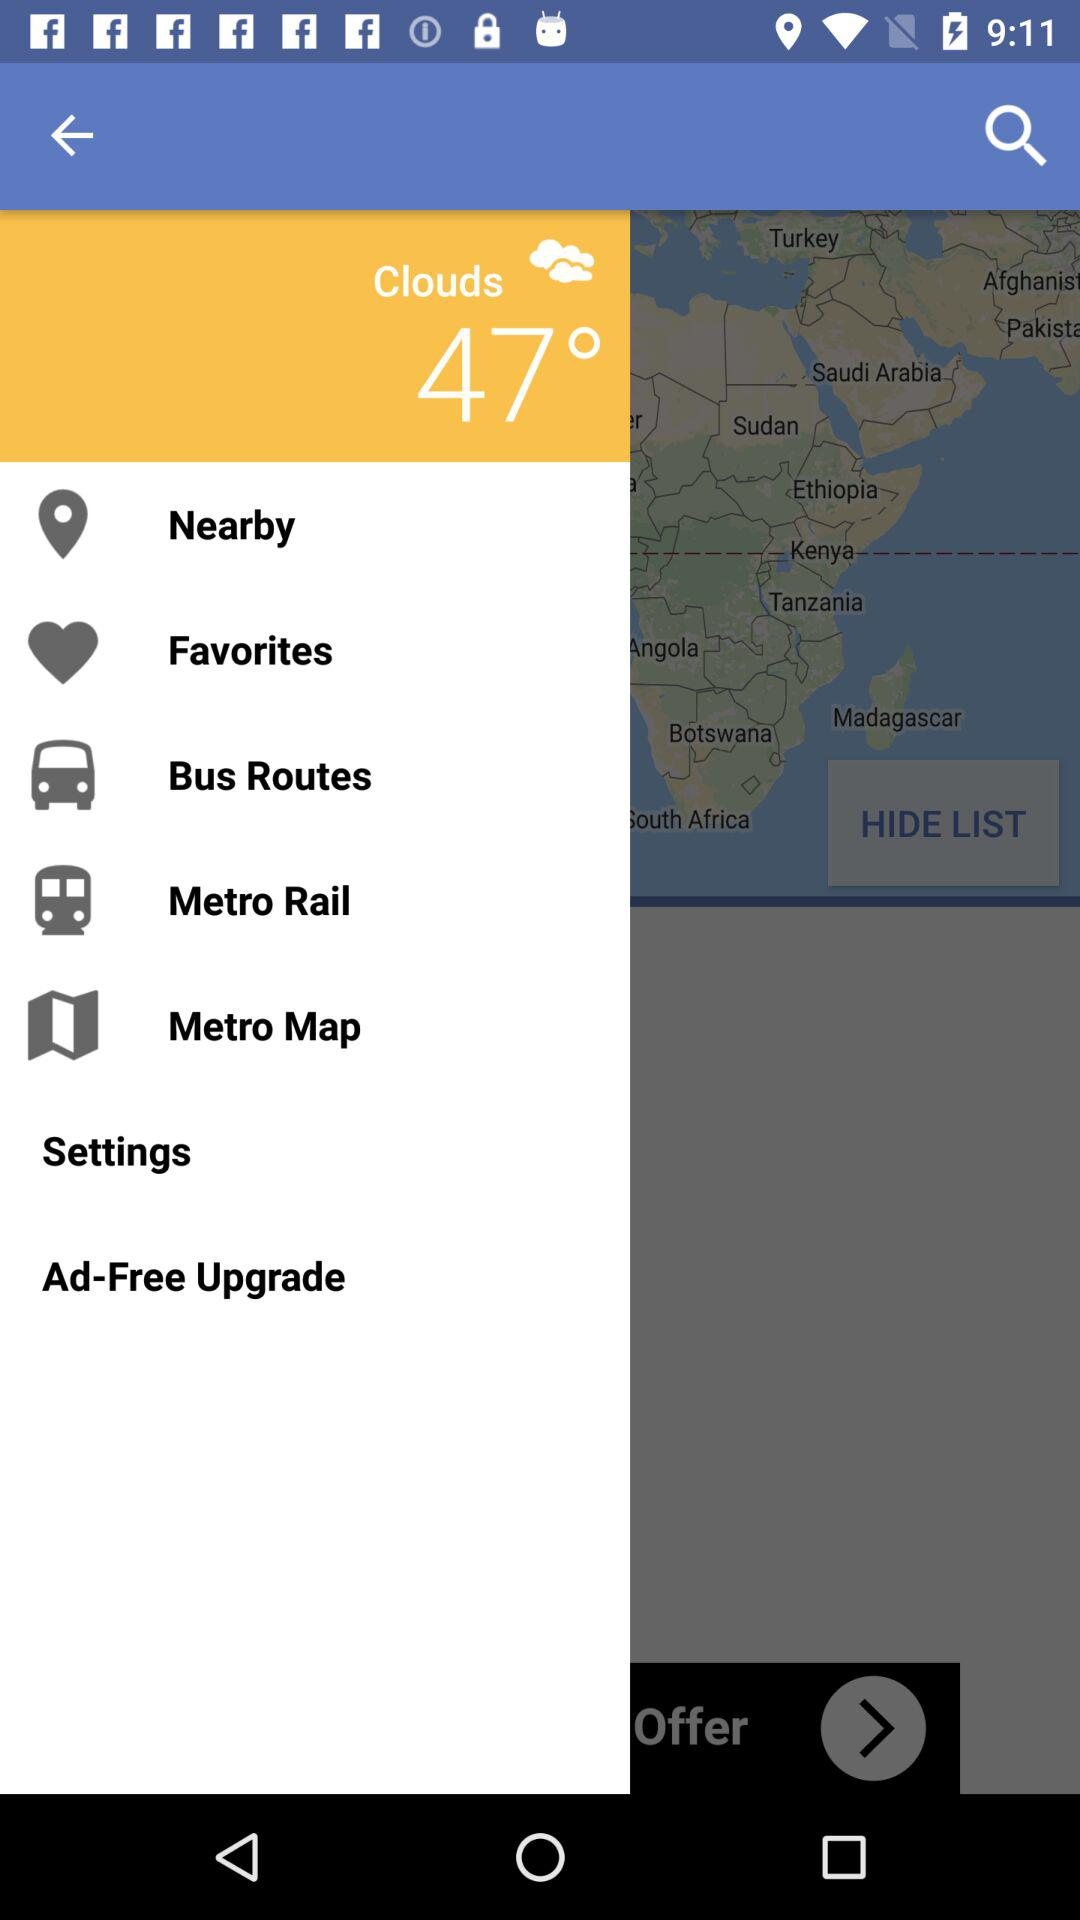Which city's bus routes are provided?
When the provided information is insufficient, respond with <no answer>. <no answer> 